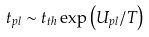<formula> <loc_0><loc_0><loc_500><loc_500>t _ { p l } \sim t _ { t h } \exp \left ( U _ { p l } / T \right )</formula> 